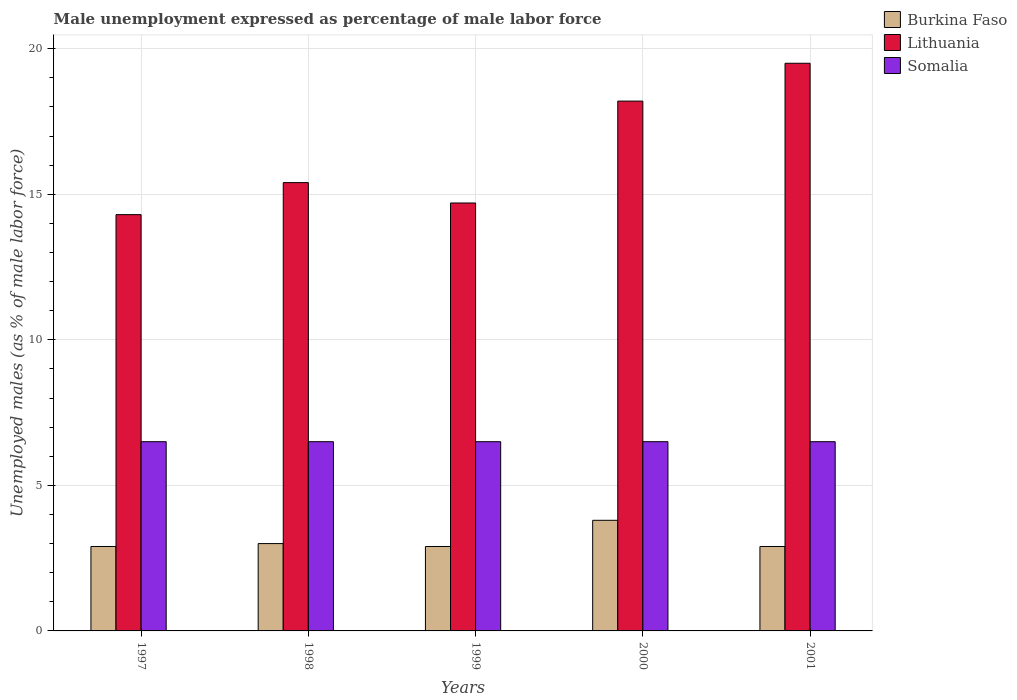How many groups of bars are there?
Your answer should be very brief. 5. How many bars are there on the 2nd tick from the right?
Ensure brevity in your answer.  3. In how many cases, is the number of bars for a given year not equal to the number of legend labels?
Provide a succinct answer. 0. What is the unemployment in males in in Lithuania in 2001?
Ensure brevity in your answer.  19.5. Across all years, what is the minimum unemployment in males in in Lithuania?
Your answer should be very brief. 14.3. In which year was the unemployment in males in in Somalia maximum?
Provide a short and direct response. 1997. In which year was the unemployment in males in in Somalia minimum?
Make the answer very short. 1997. What is the total unemployment in males in in Somalia in the graph?
Your response must be concise. 32.5. What is the difference between the unemployment in males in in Lithuania in 2000 and the unemployment in males in in Burkina Faso in 1998?
Make the answer very short. 15.2. What is the average unemployment in males in in Lithuania per year?
Offer a terse response. 16.42. In the year 2000, what is the difference between the unemployment in males in in Burkina Faso and unemployment in males in in Lithuania?
Your answer should be very brief. -14.4. In how many years, is the unemployment in males in in Somalia greater than 17 %?
Your response must be concise. 0. What is the ratio of the unemployment in males in in Burkina Faso in 1997 to that in 1998?
Ensure brevity in your answer.  0.97. Is the unemployment in males in in Somalia in 1997 less than that in 2001?
Your answer should be compact. No. Is the difference between the unemployment in males in in Burkina Faso in 1998 and 2001 greater than the difference between the unemployment in males in in Lithuania in 1998 and 2001?
Your answer should be compact. Yes. What is the difference between the highest and the second highest unemployment in males in in Lithuania?
Offer a very short reply. 1.3. What is the difference between the highest and the lowest unemployment in males in in Somalia?
Provide a succinct answer. 0. Is the sum of the unemployment in males in in Lithuania in 1999 and 2000 greater than the maximum unemployment in males in in Somalia across all years?
Keep it short and to the point. Yes. What does the 2nd bar from the left in 2001 represents?
Provide a succinct answer. Lithuania. What does the 3rd bar from the right in 2001 represents?
Make the answer very short. Burkina Faso. Is it the case that in every year, the sum of the unemployment in males in in Lithuania and unemployment in males in in Somalia is greater than the unemployment in males in in Burkina Faso?
Make the answer very short. Yes. How many years are there in the graph?
Make the answer very short. 5. Does the graph contain any zero values?
Your answer should be very brief. No. Where does the legend appear in the graph?
Offer a very short reply. Top right. How many legend labels are there?
Your answer should be compact. 3. What is the title of the graph?
Keep it short and to the point. Male unemployment expressed as percentage of male labor force. What is the label or title of the X-axis?
Your response must be concise. Years. What is the label or title of the Y-axis?
Make the answer very short. Unemployed males (as % of male labor force). What is the Unemployed males (as % of male labor force) of Burkina Faso in 1997?
Offer a terse response. 2.9. What is the Unemployed males (as % of male labor force) of Lithuania in 1997?
Your answer should be compact. 14.3. What is the Unemployed males (as % of male labor force) of Somalia in 1997?
Provide a succinct answer. 6.5. What is the Unemployed males (as % of male labor force) of Burkina Faso in 1998?
Ensure brevity in your answer.  3. What is the Unemployed males (as % of male labor force) in Lithuania in 1998?
Your answer should be very brief. 15.4. What is the Unemployed males (as % of male labor force) of Somalia in 1998?
Ensure brevity in your answer.  6.5. What is the Unemployed males (as % of male labor force) in Burkina Faso in 1999?
Make the answer very short. 2.9. What is the Unemployed males (as % of male labor force) in Lithuania in 1999?
Offer a very short reply. 14.7. What is the Unemployed males (as % of male labor force) of Somalia in 1999?
Give a very brief answer. 6.5. What is the Unemployed males (as % of male labor force) in Burkina Faso in 2000?
Ensure brevity in your answer.  3.8. What is the Unemployed males (as % of male labor force) in Lithuania in 2000?
Provide a short and direct response. 18.2. What is the Unemployed males (as % of male labor force) in Somalia in 2000?
Give a very brief answer. 6.5. What is the Unemployed males (as % of male labor force) in Burkina Faso in 2001?
Provide a succinct answer. 2.9. Across all years, what is the maximum Unemployed males (as % of male labor force) of Burkina Faso?
Offer a terse response. 3.8. Across all years, what is the maximum Unemployed males (as % of male labor force) in Lithuania?
Give a very brief answer. 19.5. Across all years, what is the maximum Unemployed males (as % of male labor force) in Somalia?
Make the answer very short. 6.5. Across all years, what is the minimum Unemployed males (as % of male labor force) in Burkina Faso?
Keep it short and to the point. 2.9. Across all years, what is the minimum Unemployed males (as % of male labor force) of Lithuania?
Keep it short and to the point. 14.3. Across all years, what is the minimum Unemployed males (as % of male labor force) in Somalia?
Your answer should be compact. 6.5. What is the total Unemployed males (as % of male labor force) in Burkina Faso in the graph?
Your answer should be very brief. 15.5. What is the total Unemployed males (as % of male labor force) of Lithuania in the graph?
Offer a terse response. 82.1. What is the total Unemployed males (as % of male labor force) in Somalia in the graph?
Make the answer very short. 32.5. What is the difference between the Unemployed males (as % of male labor force) in Lithuania in 1997 and that in 1998?
Your response must be concise. -1.1. What is the difference between the Unemployed males (as % of male labor force) of Somalia in 1997 and that in 1998?
Your answer should be very brief. 0. What is the difference between the Unemployed males (as % of male labor force) in Lithuania in 1997 and that in 1999?
Your answer should be compact. -0.4. What is the difference between the Unemployed males (as % of male labor force) of Somalia in 1997 and that in 1999?
Provide a succinct answer. 0. What is the difference between the Unemployed males (as % of male labor force) in Lithuania in 1997 and that in 2000?
Provide a succinct answer. -3.9. What is the difference between the Unemployed males (as % of male labor force) of Somalia in 1997 and that in 2000?
Provide a short and direct response. 0. What is the difference between the Unemployed males (as % of male labor force) in Burkina Faso in 1997 and that in 2001?
Make the answer very short. 0. What is the difference between the Unemployed males (as % of male labor force) of Lithuania in 1997 and that in 2001?
Provide a succinct answer. -5.2. What is the difference between the Unemployed males (as % of male labor force) in Burkina Faso in 1998 and that in 1999?
Provide a succinct answer. 0.1. What is the difference between the Unemployed males (as % of male labor force) of Lithuania in 1998 and that in 1999?
Your answer should be compact. 0.7. What is the difference between the Unemployed males (as % of male labor force) in Lithuania in 1998 and that in 2000?
Provide a succinct answer. -2.8. What is the difference between the Unemployed males (as % of male labor force) in Somalia in 1998 and that in 2001?
Your response must be concise. 0. What is the difference between the Unemployed males (as % of male labor force) of Lithuania in 1999 and that in 2000?
Give a very brief answer. -3.5. What is the difference between the Unemployed males (as % of male labor force) of Somalia in 1999 and that in 2000?
Your answer should be compact. 0. What is the difference between the Unemployed males (as % of male labor force) of Somalia in 1999 and that in 2001?
Your answer should be very brief. 0. What is the difference between the Unemployed males (as % of male labor force) of Lithuania in 2000 and that in 2001?
Ensure brevity in your answer.  -1.3. What is the difference between the Unemployed males (as % of male labor force) in Burkina Faso in 1997 and the Unemployed males (as % of male labor force) in Lithuania in 1998?
Provide a short and direct response. -12.5. What is the difference between the Unemployed males (as % of male labor force) in Burkina Faso in 1997 and the Unemployed males (as % of male labor force) in Somalia in 1998?
Your answer should be compact. -3.6. What is the difference between the Unemployed males (as % of male labor force) of Burkina Faso in 1997 and the Unemployed males (as % of male labor force) of Lithuania in 1999?
Keep it short and to the point. -11.8. What is the difference between the Unemployed males (as % of male labor force) of Burkina Faso in 1997 and the Unemployed males (as % of male labor force) of Somalia in 1999?
Provide a succinct answer. -3.6. What is the difference between the Unemployed males (as % of male labor force) in Burkina Faso in 1997 and the Unemployed males (as % of male labor force) in Lithuania in 2000?
Provide a short and direct response. -15.3. What is the difference between the Unemployed males (as % of male labor force) of Burkina Faso in 1997 and the Unemployed males (as % of male labor force) of Somalia in 2000?
Ensure brevity in your answer.  -3.6. What is the difference between the Unemployed males (as % of male labor force) in Lithuania in 1997 and the Unemployed males (as % of male labor force) in Somalia in 2000?
Ensure brevity in your answer.  7.8. What is the difference between the Unemployed males (as % of male labor force) of Burkina Faso in 1997 and the Unemployed males (as % of male labor force) of Lithuania in 2001?
Give a very brief answer. -16.6. What is the difference between the Unemployed males (as % of male labor force) of Lithuania in 1997 and the Unemployed males (as % of male labor force) of Somalia in 2001?
Your answer should be compact. 7.8. What is the difference between the Unemployed males (as % of male labor force) in Lithuania in 1998 and the Unemployed males (as % of male labor force) in Somalia in 1999?
Give a very brief answer. 8.9. What is the difference between the Unemployed males (as % of male labor force) in Burkina Faso in 1998 and the Unemployed males (as % of male labor force) in Lithuania in 2000?
Provide a succinct answer. -15.2. What is the difference between the Unemployed males (as % of male labor force) of Burkina Faso in 1998 and the Unemployed males (as % of male labor force) of Somalia in 2000?
Your answer should be very brief. -3.5. What is the difference between the Unemployed males (as % of male labor force) in Lithuania in 1998 and the Unemployed males (as % of male labor force) in Somalia in 2000?
Your answer should be very brief. 8.9. What is the difference between the Unemployed males (as % of male labor force) of Burkina Faso in 1998 and the Unemployed males (as % of male labor force) of Lithuania in 2001?
Ensure brevity in your answer.  -16.5. What is the difference between the Unemployed males (as % of male labor force) in Lithuania in 1998 and the Unemployed males (as % of male labor force) in Somalia in 2001?
Ensure brevity in your answer.  8.9. What is the difference between the Unemployed males (as % of male labor force) of Burkina Faso in 1999 and the Unemployed males (as % of male labor force) of Lithuania in 2000?
Offer a terse response. -15.3. What is the difference between the Unemployed males (as % of male labor force) in Burkina Faso in 1999 and the Unemployed males (as % of male labor force) in Somalia in 2000?
Provide a succinct answer. -3.6. What is the difference between the Unemployed males (as % of male labor force) in Lithuania in 1999 and the Unemployed males (as % of male labor force) in Somalia in 2000?
Make the answer very short. 8.2. What is the difference between the Unemployed males (as % of male labor force) in Burkina Faso in 1999 and the Unemployed males (as % of male labor force) in Lithuania in 2001?
Offer a terse response. -16.6. What is the difference between the Unemployed males (as % of male labor force) in Lithuania in 1999 and the Unemployed males (as % of male labor force) in Somalia in 2001?
Offer a very short reply. 8.2. What is the difference between the Unemployed males (as % of male labor force) in Burkina Faso in 2000 and the Unemployed males (as % of male labor force) in Lithuania in 2001?
Offer a very short reply. -15.7. What is the difference between the Unemployed males (as % of male labor force) of Burkina Faso in 2000 and the Unemployed males (as % of male labor force) of Somalia in 2001?
Offer a very short reply. -2.7. What is the average Unemployed males (as % of male labor force) of Lithuania per year?
Your response must be concise. 16.42. In the year 1997, what is the difference between the Unemployed males (as % of male labor force) of Burkina Faso and Unemployed males (as % of male labor force) of Lithuania?
Make the answer very short. -11.4. In the year 1997, what is the difference between the Unemployed males (as % of male labor force) of Lithuania and Unemployed males (as % of male labor force) of Somalia?
Offer a very short reply. 7.8. In the year 1998, what is the difference between the Unemployed males (as % of male labor force) in Burkina Faso and Unemployed males (as % of male labor force) in Somalia?
Provide a short and direct response. -3.5. In the year 1998, what is the difference between the Unemployed males (as % of male labor force) in Lithuania and Unemployed males (as % of male labor force) in Somalia?
Provide a short and direct response. 8.9. In the year 1999, what is the difference between the Unemployed males (as % of male labor force) in Lithuania and Unemployed males (as % of male labor force) in Somalia?
Make the answer very short. 8.2. In the year 2000, what is the difference between the Unemployed males (as % of male labor force) in Burkina Faso and Unemployed males (as % of male labor force) in Lithuania?
Your answer should be compact. -14.4. In the year 2000, what is the difference between the Unemployed males (as % of male labor force) of Burkina Faso and Unemployed males (as % of male labor force) of Somalia?
Provide a short and direct response. -2.7. In the year 2001, what is the difference between the Unemployed males (as % of male labor force) in Burkina Faso and Unemployed males (as % of male labor force) in Lithuania?
Your answer should be very brief. -16.6. In the year 2001, what is the difference between the Unemployed males (as % of male labor force) of Burkina Faso and Unemployed males (as % of male labor force) of Somalia?
Offer a very short reply. -3.6. In the year 2001, what is the difference between the Unemployed males (as % of male labor force) in Lithuania and Unemployed males (as % of male labor force) in Somalia?
Provide a succinct answer. 13. What is the ratio of the Unemployed males (as % of male labor force) in Burkina Faso in 1997 to that in 1998?
Make the answer very short. 0.97. What is the ratio of the Unemployed males (as % of male labor force) in Lithuania in 1997 to that in 1998?
Your answer should be very brief. 0.93. What is the ratio of the Unemployed males (as % of male labor force) of Lithuania in 1997 to that in 1999?
Give a very brief answer. 0.97. What is the ratio of the Unemployed males (as % of male labor force) of Somalia in 1997 to that in 1999?
Your response must be concise. 1. What is the ratio of the Unemployed males (as % of male labor force) of Burkina Faso in 1997 to that in 2000?
Offer a very short reply. 0.76. What is the ratio of the Unemployed males (as % of male labor force) in Lithuania in 1997 to that in 2000?
Your answer should be compact. 0.79. What is the ratio of the Unemployed males (as % of male labor force) of Somalia in 1997 to that in 2000?
Offer a terse response. 1. What is the ratio of the Unemployed males (as % of male labor force) of Lithuania in 1997 to that in 2001?
Give a very brief answer. 0.73. What is the ratio of the Unemployed males (as % of male labor force) of Somalia in 1997 to that in 2001?
Make the answer very short. 1. What is the ratio of the Unemployed males (as % of male labor force) of Burkina Faso in 1998 to that in 1999?
Give a very brief answer. 1.03. What is the ratio of the Unemployed males (as % of male labor force) in Lithuania in 1998 to that in 1999?
Your answer should be compact. 1.05. What is the ratio of the Unemployed males (as % of male labor force) in Burkina Faso in 1998 to that in 2000?
Your response must be concise. 0.79. What is the ratio of the Unemployed males (as % of male labor force) of Lithuania in 1998 to that in 2000?
Your answer should be compact. 0.85. What is the ratio of the Unemployed males (as % of male labor force) in Burkina Faso in 1998 to that in 2001?
Keep it short and to the point. 1.03. What is the ratio of the Unemployed males (as % of male labor force) in Lithuania in 1998 to that in 2001?
Make the answer very short. 0.79. What is the ratio of the Unemployed males (as % of male labor force) in Burkina Faso in 1999 to that in 2000?
Provide a short and direct response. 0.76. What is the ratio of the Unemployed males (as % of male labor force) in Lithuania in 1999 to that in 2000?
Provide a short and direct response. 0.81. What is the ratio of the Unemployed males (as % of male labor force) in Somalia in 1999 to that in 2000?
Your answer should be very brief. 1. What is the ratio of the Unemployed males (as % of male labor force) in Burkina Faso in 1999 to that in 2001?
Make the answer very short. 1. What is the ratio of the Unemployed males (as % of male labor force) of Lithuania in 1999 to that in 2001?
Offer a very short reply. 0.75. What is the ratio of the Unemployed males (as % of male labor force) of Burkina Faso in 2000 to that in 2001?
Make the answer very short. 1.31. What is the difference between the highest and the second highest Unemployed males (as % of male labor force) of Burkina Faso?
Your answer should be very brief. 0.8. What is the difference between the highest and the second highest Unemployed males (as % of male labor force) in Lithuania?
Give a very brief answer. 1.3. What is the difference between the highest and the second highest Unemployed males (as % of male labor force) of Somalia?
Offer a terse response. 0. What is the difference between the highest and the lowest Unemployed males (as % of male labor force) in Burkina Faso?
Offer a terse response. 0.9. What is the difference between the highest and the lowest Unemployed males (as % of male labor force) in Lithuania?
Provide a short and direct response. 5.2. 